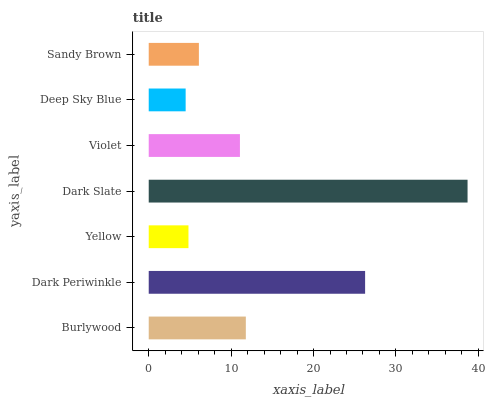Is Deep Sky Blue the minimum?
Answer yes or no. Yes. Is Dark Slate the maximum?
Answer yes or no. Yes. Is Dark Periwinkle the minimum?
Answer yes or no. No. Is Dark Periwinkle the maximum?
Answer yes or no. No. Is Dark Periwinkle greater than Burlywood?
Answer yes or no. Yes. Is Burlywood less than Dark Periwinkle?
Answer yes or no. Yes. Is Burlywood greater than Dark Periwinkle?
Answer yes or no. No. Is Dark Periwinkle less than Burlywood?
Answer yes or no. No. Is Violet the high median?
Answer yes or no. Yes. Is Violet the low median?
Answer yes or no. Yes. Is Burlywood the high median?
Answer yes or no. No. Is Burlywood the low median?
Answer yes or no. No. 